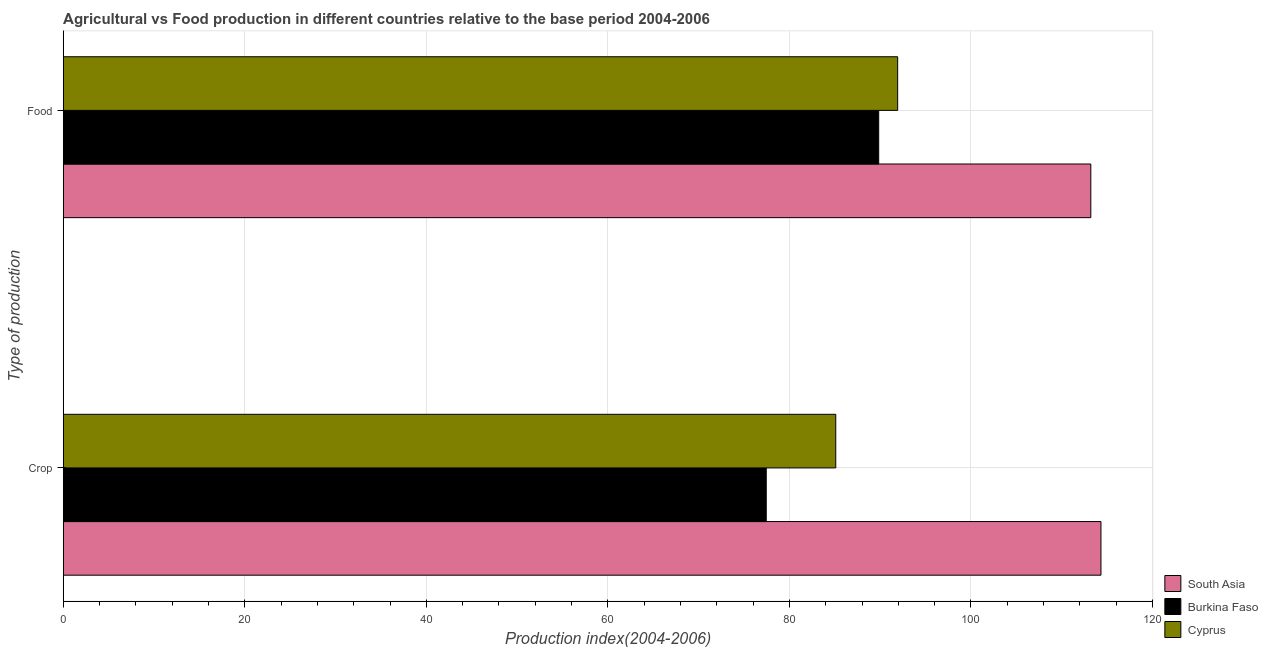How many groups of bars are there?
Ensure brevity in your answer.  2. Are the number of bars per tick equal to the number of legend labels?
Your answer should be compact. Yes. Are the number of bars on each tick of the Y-axis equal?
Provide a succinct answer. Yes. How many bars are there on the 2nd tick from the top?
Provide a succinct answer. 3. What is the label of the 2nd group of bars from the top?
Give a very brief answer. Crop. What is the food production index in South Asia?
Make the answer very short. 113.21. Across all countries, what is the maximum crop production index?
Keep it short and to the point. 114.32. Across all countries, what is the minimum food production index?
Ensure brevity in your answer.  89.84. In which country was the food production index minimum?
Make the answer very short. Burkina Faso. What is the total crop production index in the graph?
Your answer should be very brief. 276.88. What is the difference between the food production index in Burkina Faso and that in Cyprus?
Ensure brevity in your answer.  -2.09. What is the difference between the crop production index in South Asia and the food production index in Cyprus?
Your answer should be compact. 22.39. What is the average food production index per country?
Provide a short and direct response. 98.33. What is the difference between the crop production index and food production index in South Asia?
Ensure brevity in your answer.  1.12. In how many countries, is the crop production index greater than 8 ?
Provide a succinct answer. 3. What is the ratio of the food production index in Burkina Faso to that in South Asia?
Offer a very short reply. 0.79. What does the 1st bar from the top in Crop represents?
Your answer should be compact. Cyprus. What does the 1st bar from the bottom in Crop represents?
Make the answer very short. South Asia. How many bars are there?
Keep it short and to the point. 6. How many countries are there in the graph?
Give a very brief answer. 3. What is the difference between two consecutive major ticks on the X-axis?
Make the answer very short. 20. Are the values on the major ticks of X-axis written in scientific E-notation?
Keep it short and to the point. No. How many legend labels are there?
Give a very brief answer. 3. What is the title of the graph?
Make the answer very short. Agricultural vs Food production in different countries relative to the base period 2004-2006. What is the label or title of the X-axis?
Offer a very short reply. Production index(2004-2006). What is the label or title of the Y-axis?
Your answer should be compact. Type of production. What is the Production index(2004-2006) in South Asia in Crop?
Give a very brief answer. 114.32. What is the Production index(2004-2006) of Burkina Faso in Crop?
Offer a terse response. 77.45. What is the Production index(2004-2006) in Cyprus in Crop?
Offer a very short reply. 85.11. What is the Production index(2004-2006) in South Asia in Food?
Offer a terse response. 113.21. What is the Production index(2004-2006) in Burkina Faso in Food?
Your answer should be very brief. 89.84. What is the Production index(2004-2006) in Cyprus in Food?
Offer a terse response. 91.93. Across all Type of production, what is the maximum Production index(2004-2006) in South Asia?
Provide a short and direct response. 114.32. Across all Type of production, what is the maximum Production index(2004-2006) of Burkina Faso?
Provide a succinct answer. 89.84. Across all Type of production, what is the maximum Production index(2004-2006) in Cyprus?
Make the answer very short. 91.93. Across all Type of production, what is the minimum Production index(2004-2006) in South Asia?
Offer a terse response. 113.21. Across all Type of production, what is the minimum Production index(2004-2006) in Burkina Faso?
Keep it short and to the point. 77.45. Across all Type of production, what is the minimum Production index(2004-2006) in Cyprus?
Ensure brevity in your answer.  85.11. What is the total Production index(2004-2006) in South Asia in the graph?
Provide a succinct answer. 227.53. What is the total Production index(2004-2006) of Burkina Faso in the graph?
Ensure brevity in your answer.  167.29. What is the total Production index(2004-2006) of Cyprus in the graph?
Your answer should be compact. 177.04. What is the difference between the Production index(2004-2006) of South Asia in Crop and that in Food?
Ensure brevity in your answer.  1.12. What is the difference between the Production index(2004-2006) of Burkina Faso in Crop and that in Food?
Keep it short and to the point. -12.39. What is the difference between the Production index(2004-2006) in Cyprus in Crop and that in Food?
Keep it short and to the point. -6.82. What is the difference between the Production index(2004-2006) of South Asia in Crop and the Production index(2004-2006) of Burkina Faso in Food?
Keep it short and to the point. 24.48. What is the difference between the Production index(2004-2006) in South Asia in Crop and the Production index(2004-2006) in Cyprus in Food?
Provide a succinct answer. 22.39. What is the difference between the Production index(2004-2006) in Burkina Faso in Crop and the Production index(2004-2006) in Cyprus in Food?
Give a very brief answer. -14.48. What is the average Production index(2004-2006) in South Asia per Type of production?
Your response must be concise. 113.77. What is the average Production index(2004-2006) in Burkina Faso per Type of production?
Provide a succinct answer. 83.64. What is the average Production index(2004-2006) of Cyprus per Type of production?
Your response must be concise. 88.52. What is the difference between the Production index(2004-2006) in South Asia and Production index(2004-2006) in Burkina Faso in Crop?
Offer a terse response. 36.87. What is the difference between the Production index(2004-2006) of South Asia and Production index(2004-2006) of Cyprus in Crop?
Your response must be concise. 29.21. What is the difference between the Production index(2004-2006) of Burkina Faso and Production index(2004-2006) of Cyprus in Crop?
Your response must be concise. -7.66. What is the difference between the Production index(2004-2006) in South Asia and Production index(2004-2006) in Burkina Faso in Food?
Provide a succinct answer. 23.37. What is the difference between the Production index(2004-2006) of South Asia and Production index(2004-2006) of Cyprus in Food?
Your response must be concise. 21.28. What is the difference between the Production index(2004-2006) in Burkina Faso and Production index(2004-2006) in Cyprus in Food?
Ensure brevity in your answer.  -2.09. What is the ratio of the Production index(2004-2006) in South Asia in Crop to that in Food?
Offer a very short reply. 1.01. What is the ratio of the Production index(2004-2006) in Burkina Faso in Crop to that in Food?
Keep it short and to the point. 0.86. What is the ratio of the Production index(2004-2006) of Cyprus in Crop to that in Food?
Your answer should be compact. 0.93. What is the difference between the highest and the second highest Production index(2004-2006) in South Asia?
Give a very brief answer. 1.12. What is the difference between the highest and the second highest Production index(2004-2006) in Burkina Faso?
Provide a short and direct response. 12.39. What is the difference between the highest and the second highest Production index(2004-2006) of Cyprus?
Your answer should be very brief. 6.82. What is the difference between the highest and the lowest Production index(2004-2006) of South Asia?
Provide a short and direct response. 1.12. What is the difference between the highest and the lowest Production index(2004-2006) in Burkina Faso?
Make the answer very short. 12.39. What is the difference between the highest and the lowest Production index(2004-2006) in Cyprus?
Offer a very short reply. 6.82. 